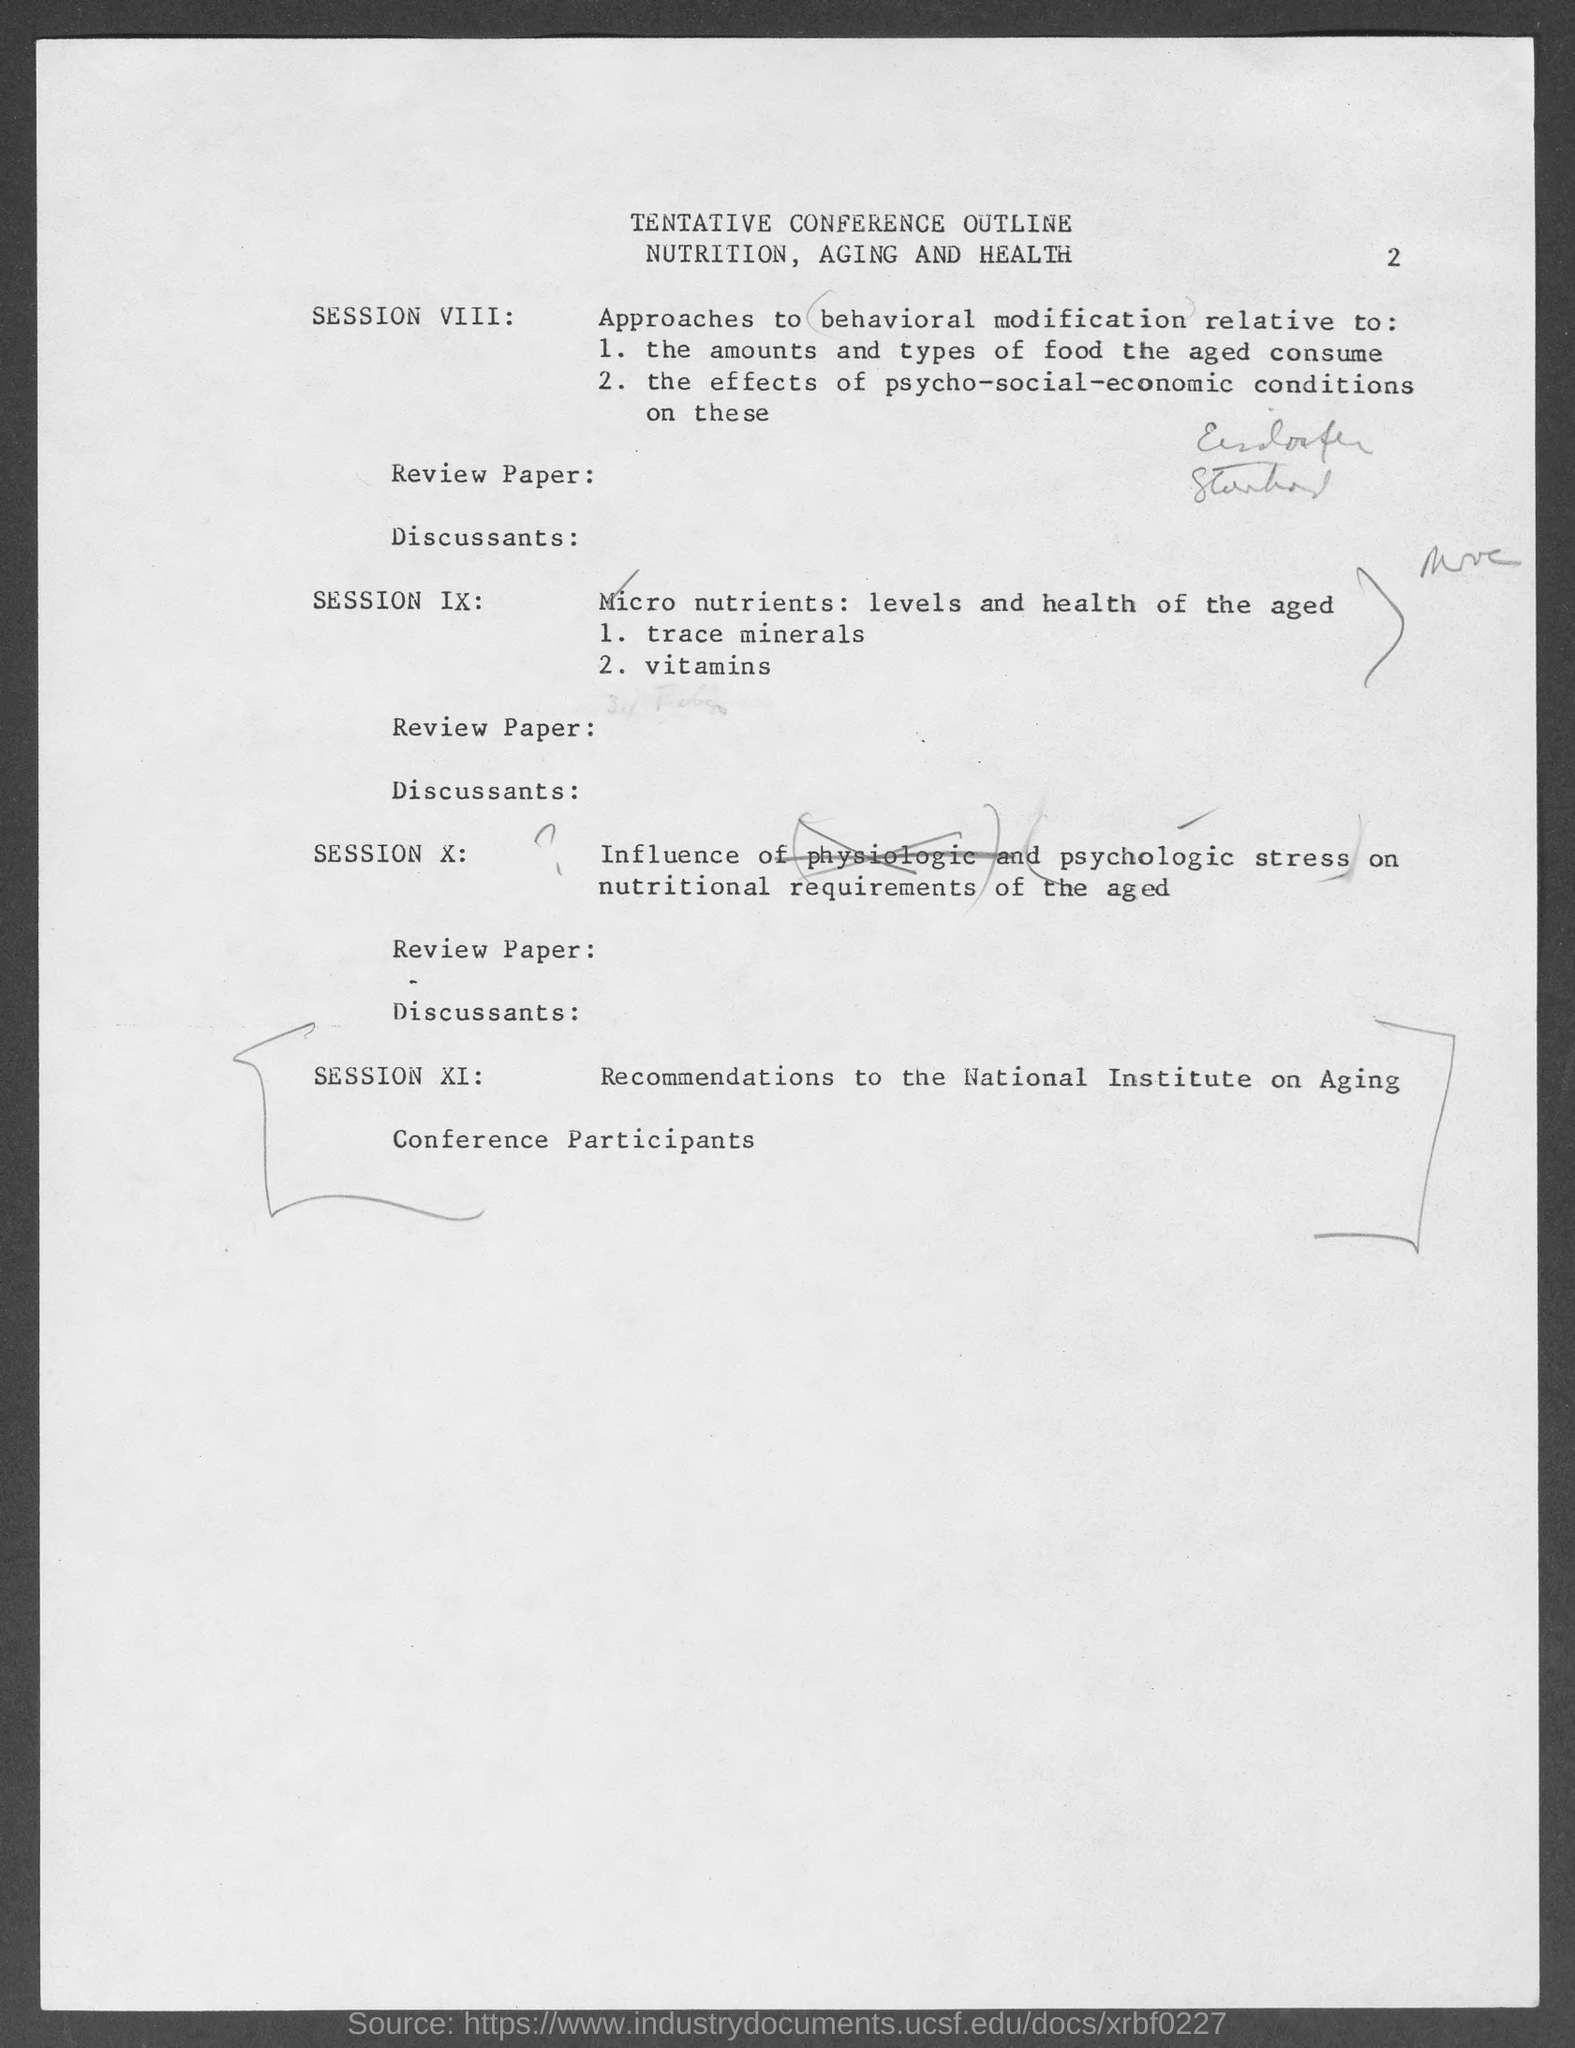Mention a couple of crucial points in this snapshot. The page number at the top of the page is two. 